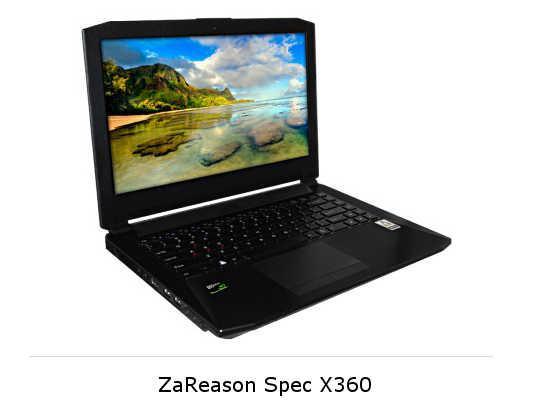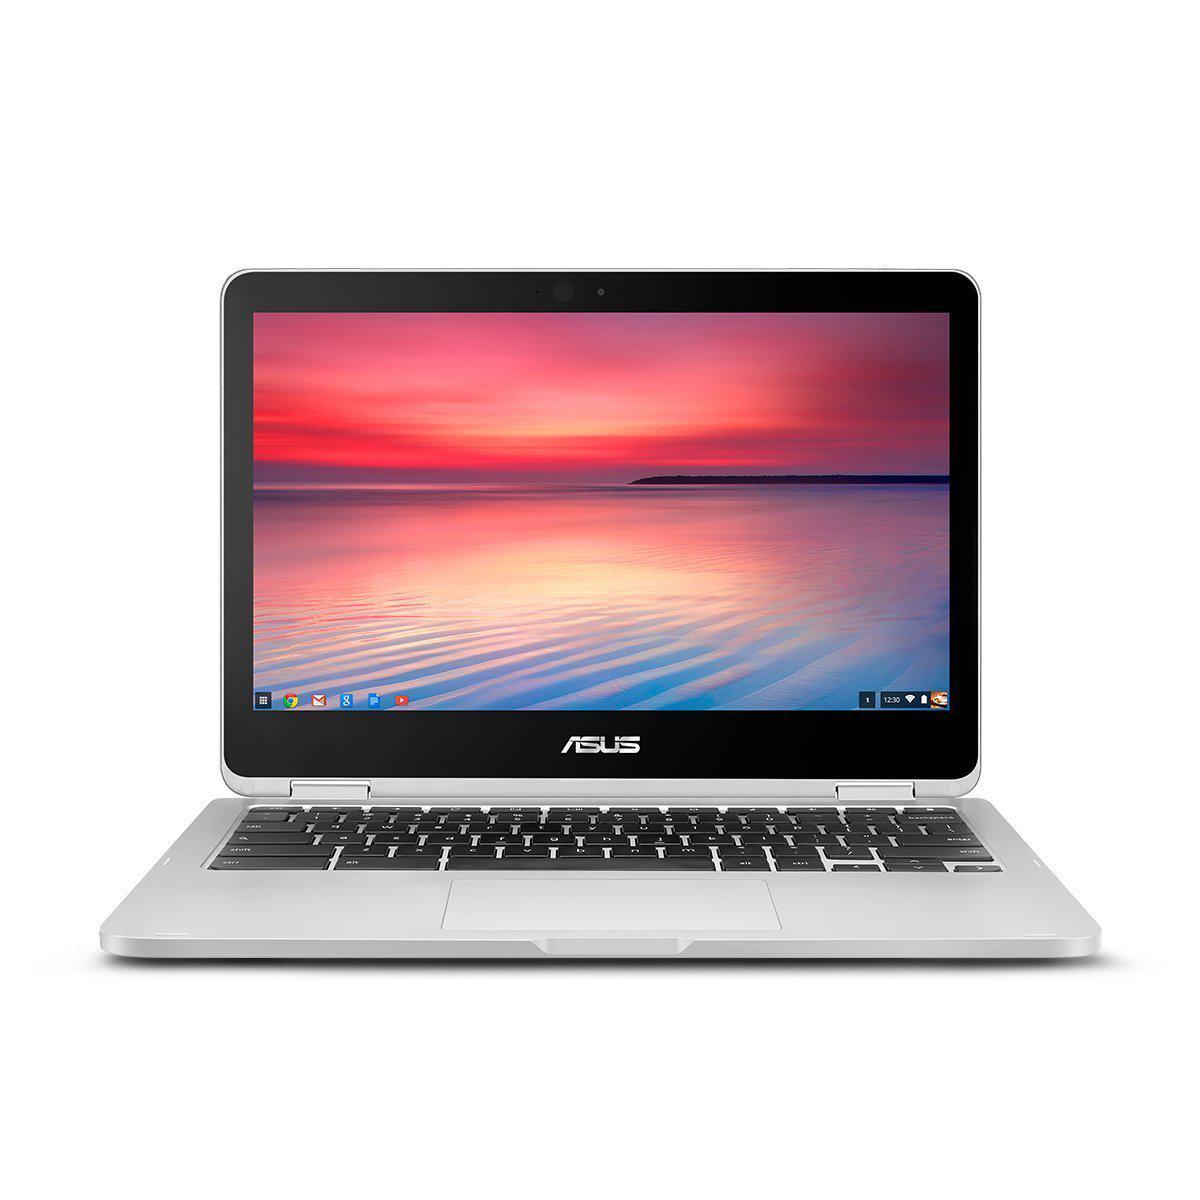The first image is the image on the left, the second image is the image on the right. For the images shown, is this caption "One open laptop faces straight forward, and the other is turned at an angle but not held by a hand." true? Answer yes or no. Yes. The first image is the image on the left, the second image is the image on the right. Examine the images to the left and right. Is the description "The keyboard in the image on the left is black." accurate? Answer yes or no. Yes. 